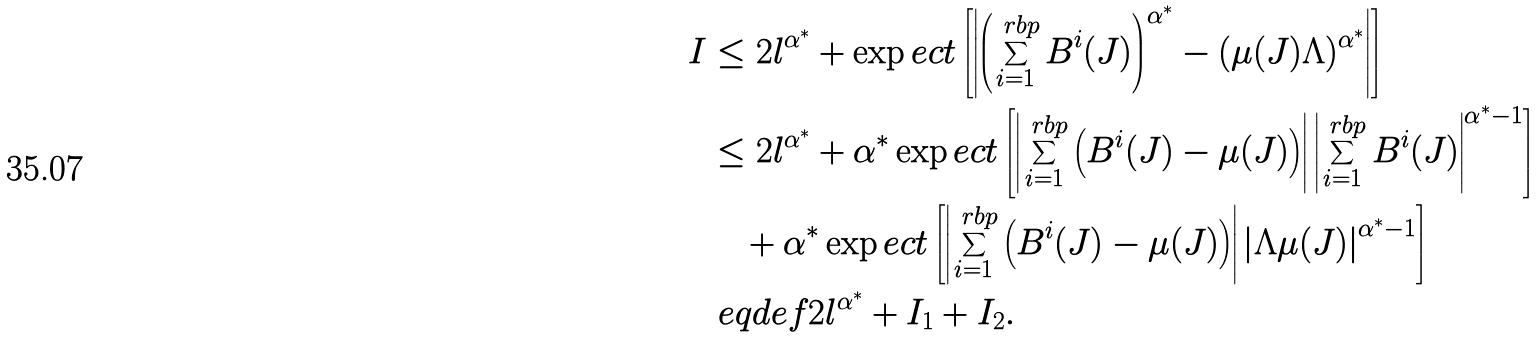Convert formula to latex. <formula><loc_0><loc_0><loc_500><loc_500>I & \leq 2 l ^ { \alpha ^ { \ast } } + \exp e c t \left [ \left | \left ( \sum _ { i = 1 } ^ { \ r b p } B ^ { i } ( J ) \right ) ^ { \alpha ^ { \ast } } - ( \mu ( J ) \Lambda ) ^ { \alpha ^ { \ast } } \right | \right ] \\ & \leq 2 l ^ { \alpha ^ { \ast } } + \alpha ^ { \ast } \exp e c t \left [ \left | \sum _ { i = 1 } ^ { \ r b p } \left ( B ^ { i } ( J ) - \mu ( J ) \right ) \right | \left | \sum _ { i = 1 } ^ { \ r b p } B ^ { i } ( J ) \right | ^ { \alpha ^ { \ast } - 1 } \right ] \\ & \quad + \alpha ^ { \ast } \exp e c t \left [ \left | \sum _ { i = 1 } ^ { \ r b p } \left ( B ^ { i } ( J ) - \mu ( J ) \right ) \right | \left | \Lambda \mu ( J ) \right | ^ { \alpha ^ { \ast } - 1 } \right ] \\ & \ e q d e f 2 l ^ { \alpha ^ { \ast } } + I _ { 1 } + I _ { 2 } .</formula> 